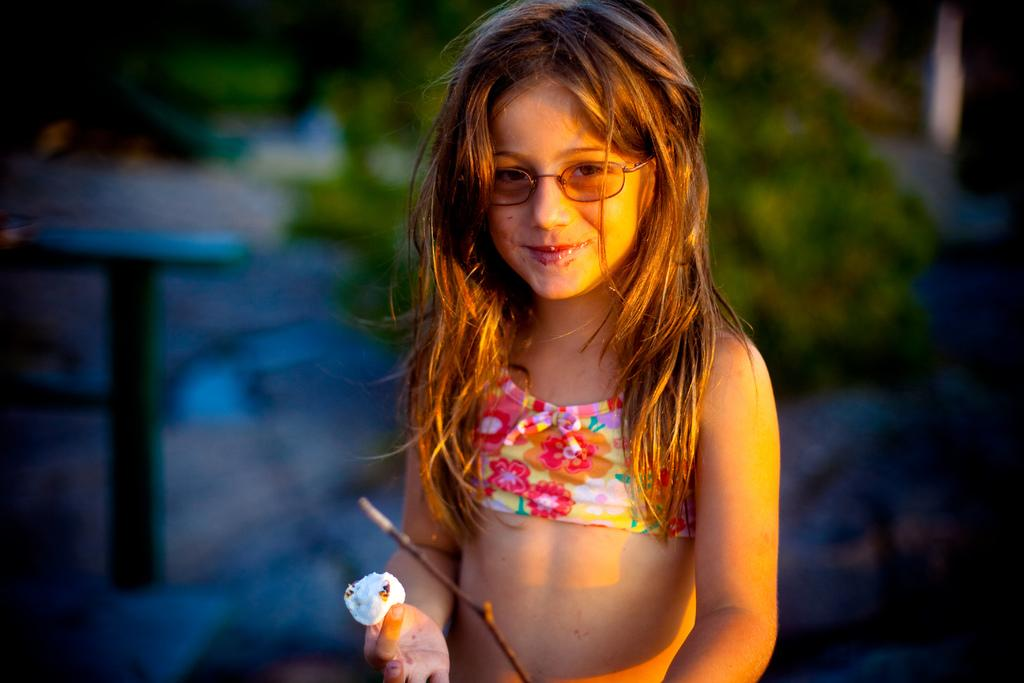What is the main subject of the image? There is a girl standing in the image. What is the girl holding in the image? The girl is holding an object. What can be seen in the background of the image? There is a table and a tree in the background of the image. What is visible at the bottom of the image? A dried stem of a plant is visible at the bottom of the image. What type of coal is the monkey using to perform division in the image? There is no monkey or coal present in the image, and division is not being performed. 